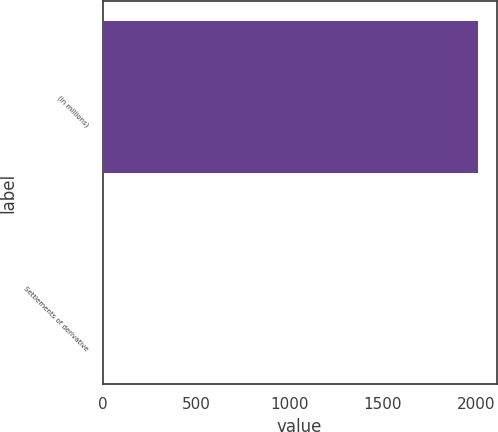<chart> <loc_0><loc_0><loc_500><loc_500><bar_chart><fcel>(In millions)<fcel>Settlements of derivative<nl><fcel>2012<fcel>2<nl></chart> 